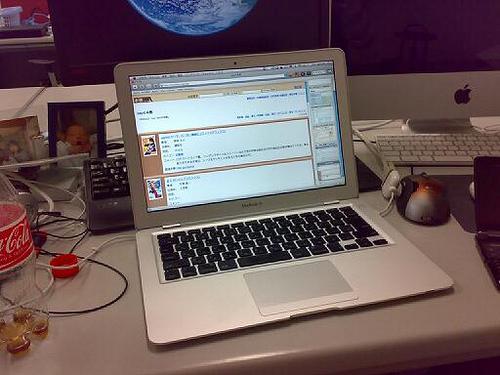Is this laptop for sale?
Write a very short answer. No. How many keyboards are there?
Give a very brief answer. 3. Is this computer compatible with a Dell?
Short answer required. No. What brand of soda is shown?
Short answer required. Coca cola. Is this an old laptop?
Answer briefly. No. What is the object partially behind the monitor?
Be succinct. Keyboard. What machine is this?
Short answer required. Laptop. What is on the desk?
Short answer required. Laptop. What color is the mouse?
Quick response, please. Silver. How many laptops are there?
Short answer required. 1. What color is the keyboard backlight?
Quick response, please. White. What animal is this?
Short answer required. Human. What is on the laptop's screen?
Short answer required. Words. Is there a manual next to the laptop?
Keep it brief. No. Is the soda bottle full?
Write a very short answer. No. What type of machine is in front of the monitor?
Write a very short answer. Laptop. Where is the Coke bottle located?
Be succinct. Left. Is this a tablet computer?
Answer briefly. No. How many full length fingers are visible?
Give a very brief answer. 0. What kind of computer is shown?
Write a very short answer. Laptop. 